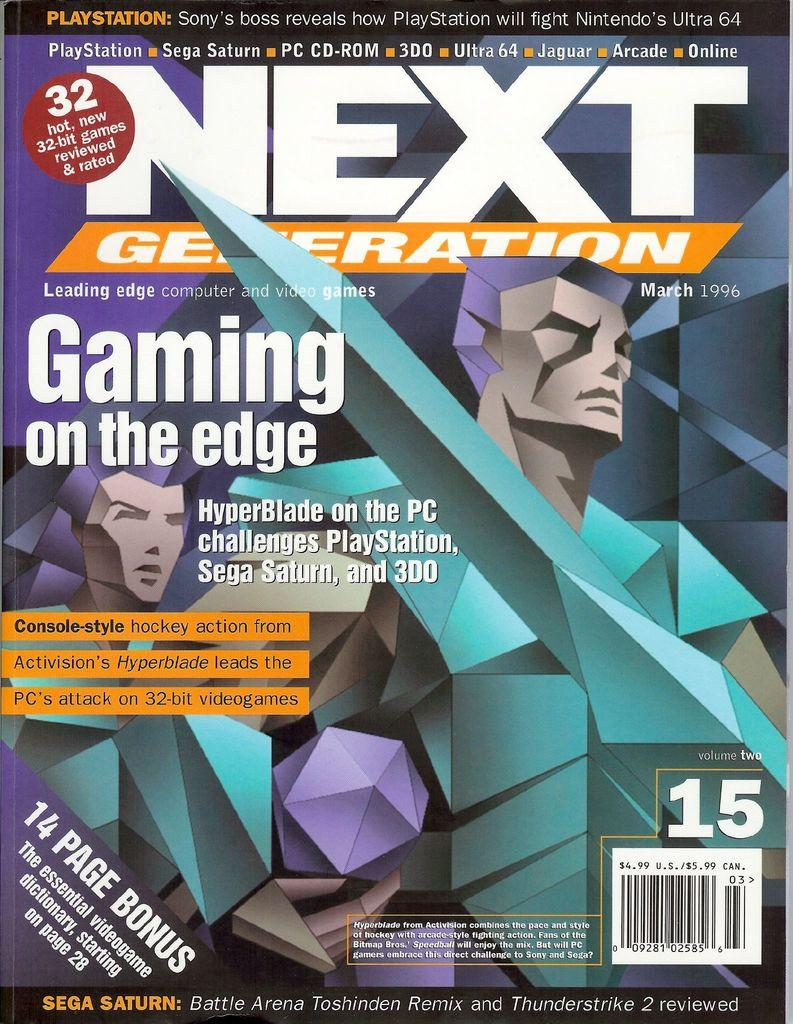<image>
Provide a brief description of the given image. A Next Generation video game issue from March 1996. 